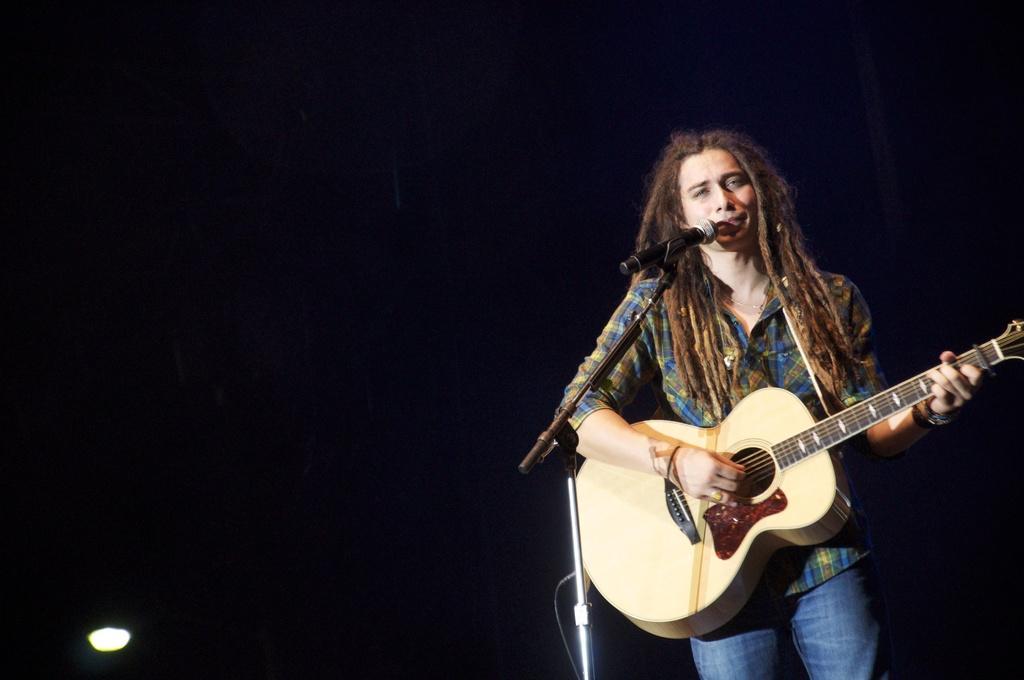How would you summarize this image in a sentence or two? In this image, There is a person standing and holding a music instrument and he is singing in microphone. 